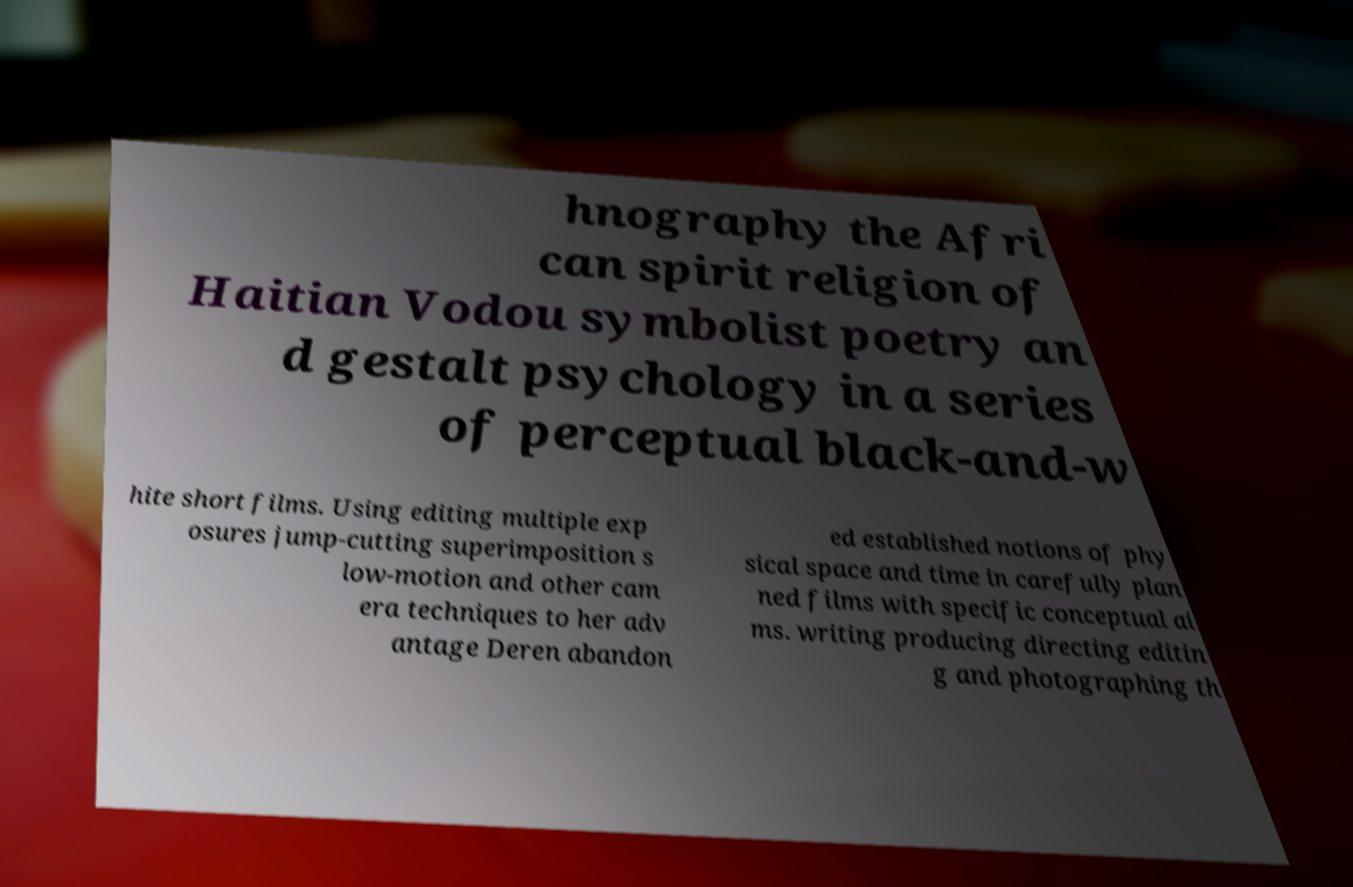What messages or text are displayed in this image? I need them in a readable, typed format. hnography the Afri can spirit religion of Haitian Vodou symbolist poetry an d gestalt psychology in a series of perceptual black-and-w hite short films. Using editing multiple exp osures jump-cutting superimposition s low-motion and other cam era techniques to her adv antage Deren abandon ed established notions of phy sical space and time in carefully plan ned films with specific conceptual ai ms. writing producing directing editin g and photographing th 